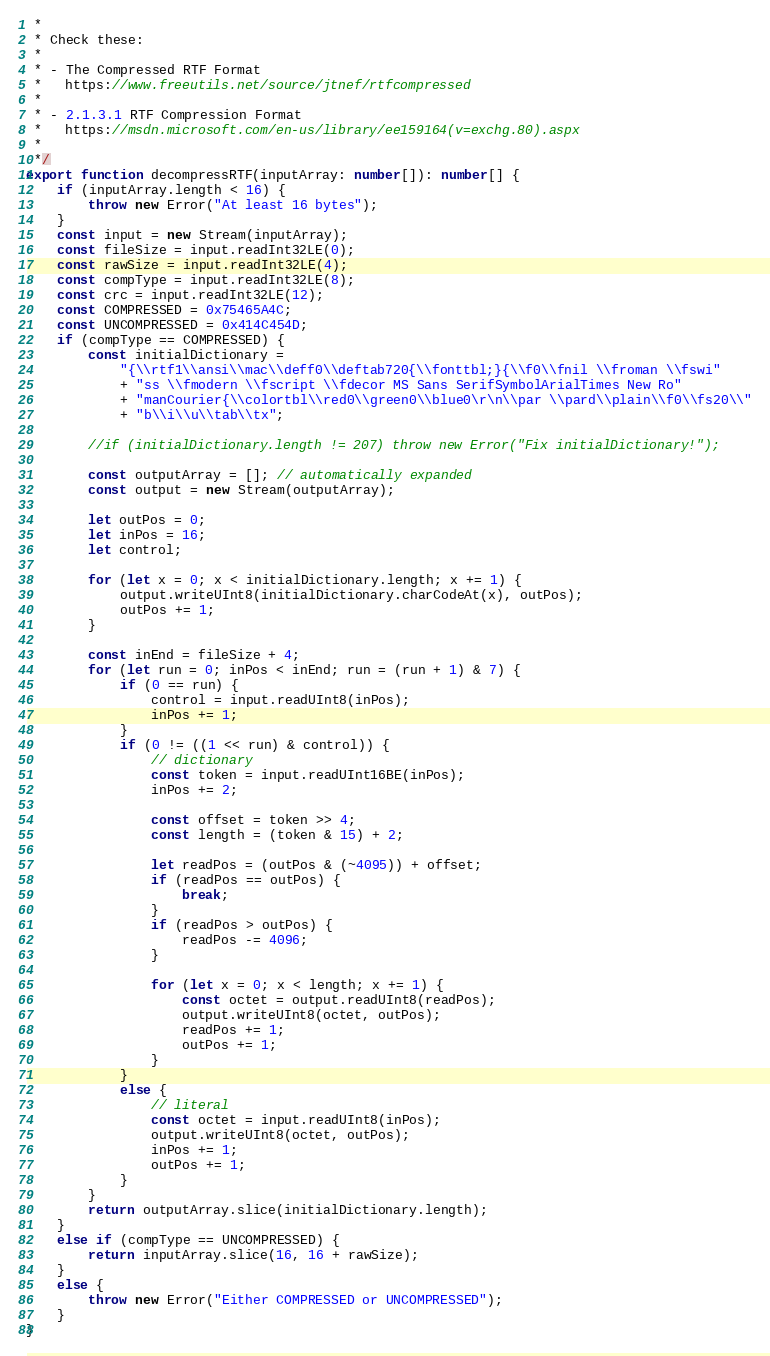Convert code to text. <code><loc_0><loc_0><loc_500><loc_500><_TypeScript_> * 
 * Check these:
 * 
 * - The Compressed RTF Format
 *   https://www.freeutils.net/source/jtnef/rtfcompressed
 * 
 * - 2.1.3.1 RTF Compression Format
 *   https://msdn.microsoft.com/en-us/library/ee159164(v=exchg.80).aspx
 * 
 */
export function decompressRTF(inputArray: number[]): number[] {
    if (inputArray.length < 16) {
        throw new Error("At least 16 bytes");
    }
    const input = new Stream(inputArray);
    const fileSize = input.readInt32LE(0);
    const rawSize = input.readInt32LE(4);
    const compType = input.readInt32LE(8);
    const crc = input.readInt32LE(12);
    const COMPRESSED = 0x75465A4C;
    const UNCOMPRESSED = 0x414C454D;
    if (compType == COMPRESSED) {
        const initialDictionary =
            "{\\rtf1\\ansi\\mac\\deff0\\deftab720{\\fonttbl;}{\\f0\\fnil \\froman \\fswi"
            + "ss \\fmodern \\fscript \\fdecor MS Sans SerifSymbolArialTimes New Ro"
            + "manCourier{\\colortbl\\red0\\green0\\blue0\r\n\\par \\pard\\plain\\f0\\fs20\\"
            + "b\\i\\u\\tab\\tx";

        //if (initialDictionary.length != 207) throw new Error("Fix initialDictionary!");

        const outputArray = []; // automatically expanded
        const output = new Stream(outputArray);

        let outPos = 0;
        let inPos = 16;
        let control;

        for (let x = 0; x < initialDictionary.length; x += 1) {
            output.writeUInt8(initialDictionary.charCodeAt(x), outPos);
            outPos += 1;
        }

        const inEnd = fileSize + 4;
        for (let run = 0; inPos < inEnd; run = (run + 1) & 7) {
            if (0 == run) {
                control = input.readUInt8(inPos);
                inPos += 1;
            }
            if (0 != ((1 << run) & control)) {
                // dictionary
                const token = input.readUInt16BE(inPos);
                inPos += 2;

                const offset = token >> 4;
                const length = (token & 15) + 2;

                let readPos = (outPos & (~4095)) + offset;
                if (readPos == outPos) {
                    break;
                }
                if (readPos > outPos) {
                    readPos -= 4096;
                }

                for (let x = 0; x < length; x += 1) {
                    const octet = output.readUInt8(readPos);
                    output.writeUInt8(octet, outPos);
                    readPos += 1;
                    outPos += 1;
                }
            }
            else {
                // literal
                const octet = input.readUInt8(inPos);
                output.writeUInt8(octet, outPos);
                inPos += 1;
                outPos += 1;
            }
        }
        return outputArray.slice(initialDictionary.length);
    }
    else if (compType == UNCOMPRESSED) {
        return inputArray.slice(16, 16 + rawSize);
    }
    else {
        throw new Error("Either COMPRESSED or UNCOMPRESSED");
    }
}
</code> 